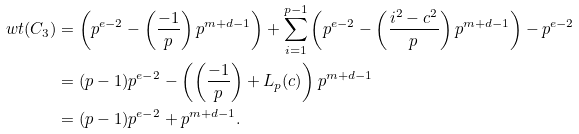<formula> <loc_0><loc_0><loc_500><loc_500>w t ( C _ { 3 } ) & = \left ( p ^ { e - 2 } - \left ( \frac { - 1 } { p } \right ) p ^ { m + d - 1 } \right ) + \sum _ { i = 1 } ^ { p - 1 } \left ( p ^ { e - 2 } - \left ( \frac { i ^ { 2 } - c ^ { 2 } } { p } \right ) p ^ { m + d - 1 } \right ) - p ^ { e - 2 } \\ & = ( p - 1 ) p ^ { e - 2 } - \left ( \left ( \frac { - 1 } { p } \right ) + L _ { p } ( c ) \right ) p ^ { m + d - 1 } \\ & = ( p - 1 ) p ^ { e - 2 } + p ^ { m + d - 1 } .</formula> 